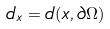<formula> <loc_0><loc_0><loc_500><loc_500>d _ { x } = d ( x , \partial \Omega )</formula> 